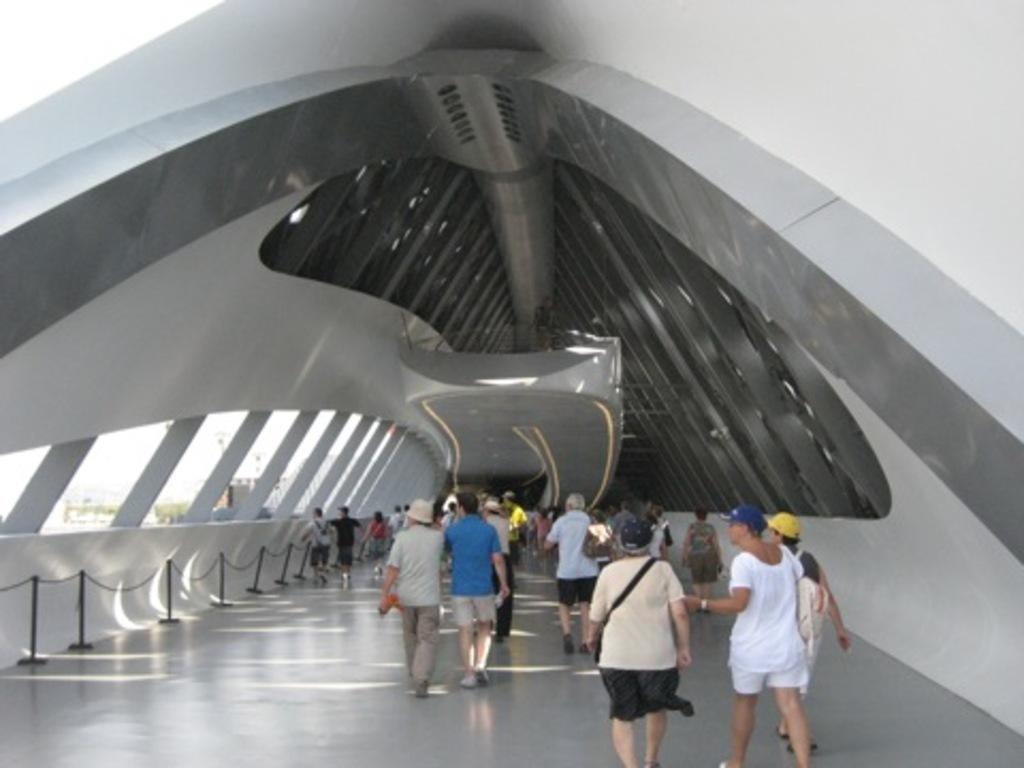Can you describe this image briefly? In this image we can see many persons walking on the floor. On the left side of the image we can see pillars, fencing, trees, buildings and sky. On the right side of the image there is wall. 